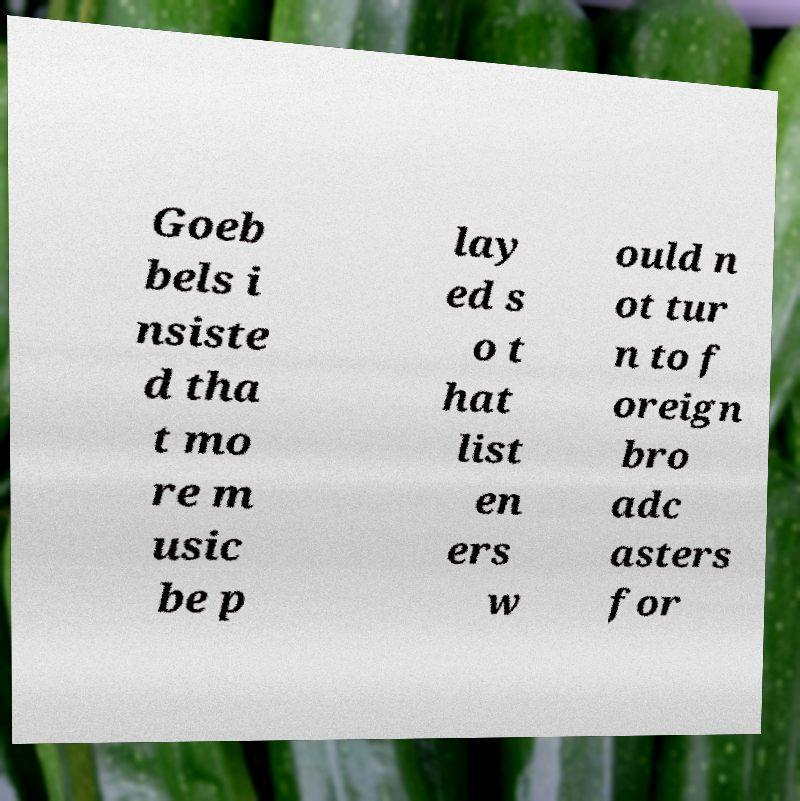Please identify and transcribe the text found in this image. Goeb bels i nsiste d tha t mo re m usic be p lay ed s o t hat list en ers w ould n ot tur n to f oreign bro adc asters for 